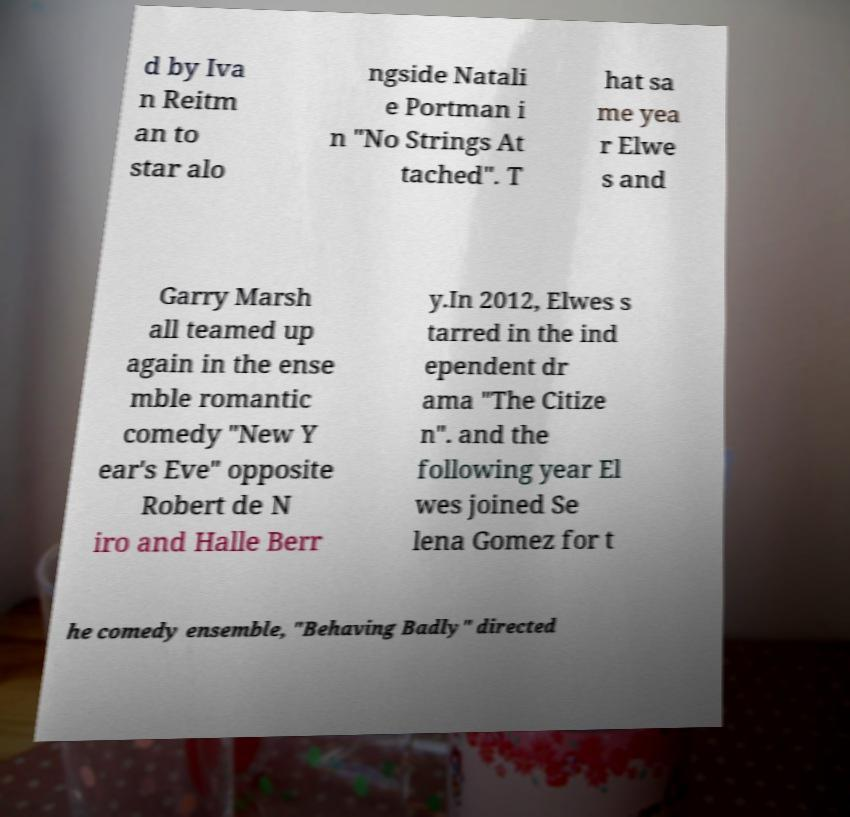For documentation purposes, I need the text within this image transcribed. Could you provide that? d by Iva n Reitm an to star alo ngside Natali e Portman i n "No Strings At tached". T hat sa me yea r Elwe s and Garry Marsh all teamed up again in the ense mble romantic comedy "New Y ear's Eve" opposite Robert de N iro and Halle Berr y.In 2012, Elwes s tarred in the ind ependent dr ama "The Citize n". and the following year El wes joined Se lena Gomez for t he comedy ensemble, "Behaving Badly" directed 